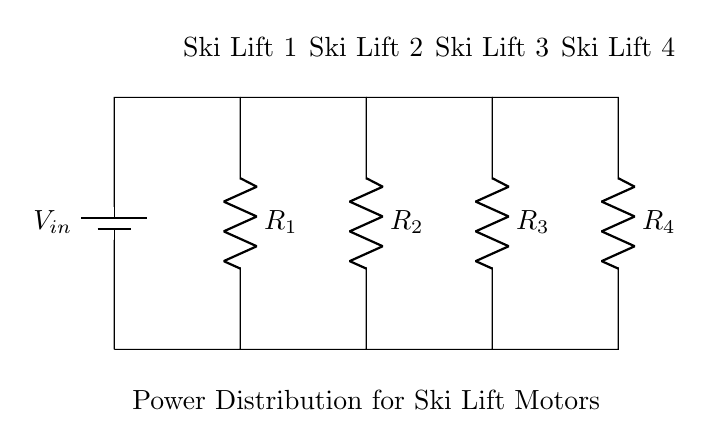What is the input voltage of the circuit? The input voltage is labeled as V_in in the diagram, which is typically the voltage supplied to the entire parallel circuit.
Answer: V_in How many resistors are in this circuit? The diagram shows four resistors labeled R_1, R_2, R_3, and R_4, indicating that there are a total of four resistors present.
Answer: Four Which ski lift has the highest resistance? The individual resistances R_1, R_2, R_3, and R_4 are not specified in the diagram; hence we cannot determine which lift has the highest resistance without additional information.
Answer: Not determinable What type of circuit is this? The circuit is designed in parallel, as evidenced by the arrangement of components being connected alongside each other, allowing voltage to remain constant across all branches.
Answer: Parallel How would the current behave across the ski lifts? In a current divider, the total current from the source divides among the parallel branches according to their resistances, with lower resistance receiving a higher share of the current.
Answer: Divided by resistance What does this circuit design ensure for the ski lifts? This parallel circuit design ensures that each ski lift motor receives an independent and consistent voltage supply while being powered simultaneously.
Answer: Independent voltage supply 